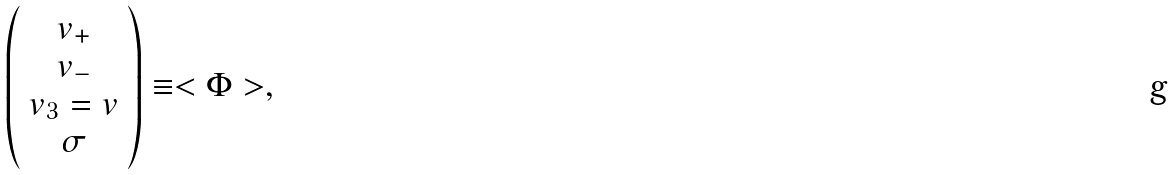<formula> <loc_0><loc_0><loc_500><loc_500>\left ( \begin{array} { c } v _ { + } \\ v _ { - } \\ v _ { 3 } = v \\ \sigma \end{array} \right ) \equiv < \Phi > ,</formula> 